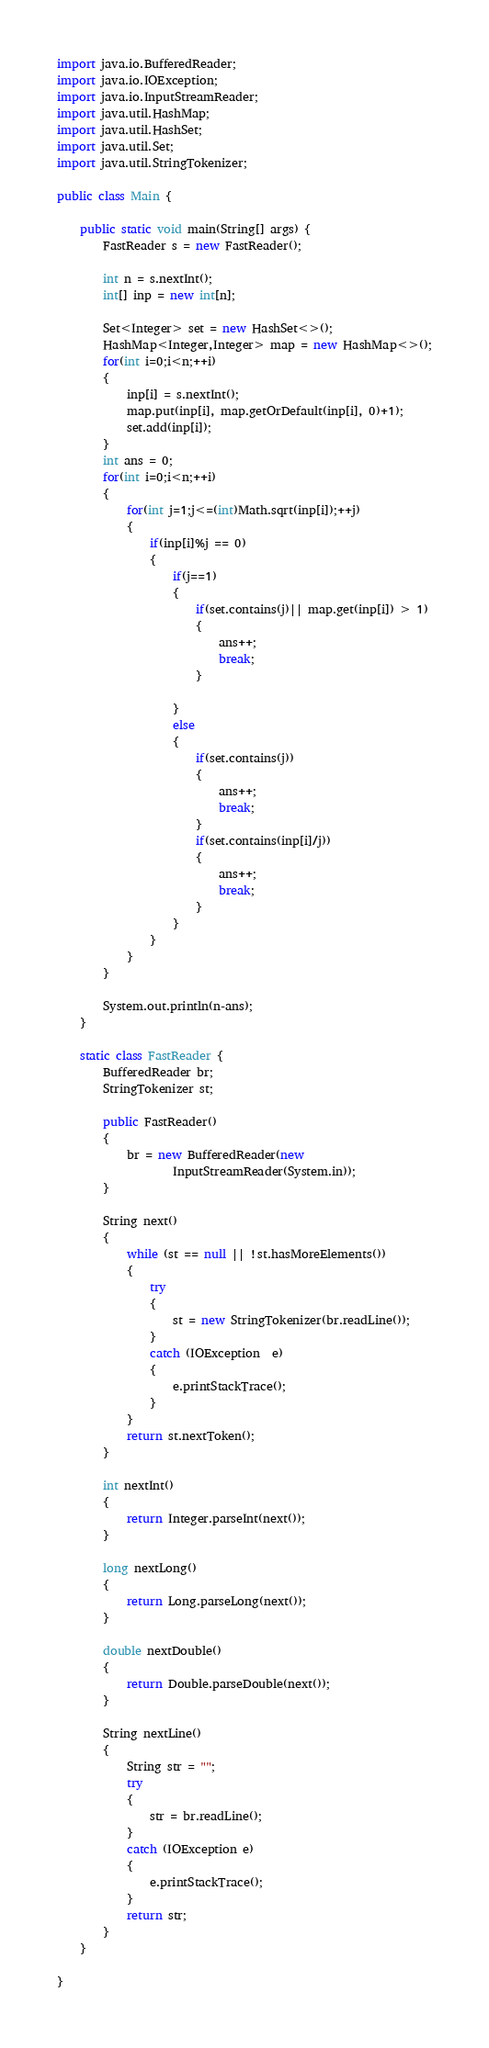<code> <loc_0><loc_0><loc_500><loc_500><_Java_>import java.io.BufferedReader;
import java.io.IOException;
import java.io.InputStreamReader;
import java.util.HashMap;
import java.util.HashSet;
import java.util.Set;
import java.util.StringTokenizer;

public class Main {

	public static void main(String[] args) {
		FastReader s = new FastReader();
	
		int n = s.nextInt();
		int[] inp = new int[n];
		
		Set<Integer> set = new HashSet<>();
		HashMap<Integer,Integer> map = new HashMap<>();
		for(int i=0;i<n;++i)
		{
			inp[i] = s.nextInt();
			map.put(inp[i], map.getOrDefault(inp[i], 0)+1);
			set.add(inp[i]);
		}
		int ans = 0;
		for(int i=0;i<n;++i)
		{
			for(int j=1;j<=(int)Math.sqrt(inp[i]);++j)
			{
				if(inp[i]%j == 0)
				{
					if(j==1)
					{
						if(set.contains(j)|| map.get(inp[i]) > 1)
						{
							ans++;
							break;
						}
							
					}
					else
					{
						if(set.contains(j))
						{
							ans++;
							break;
						}
						if(set.contains(inp[i]/j))
						{
							ans++;
							break;
						}
					}
				}
			}
		}
		
		System.out.println(n-ans);
	}
	
	static class FastReader {
        BufferedReader br;
        StringTokenizer st;
 
        public FastReader()
        {
            br = new BufferedReader(new
                    InputStreamReader(System.in));
        }
 
        String next()
        {
            while (st == null || !st.hasMoreElements())
            {
                try
                {
                    st = new StringTokenizer(br.readLine());
                }
                catch (IOException  e)
                {
                    e.printStackTrace();
                }
            }
            return st.nextToken();
        }
 
        int nextInt()
        {
            return Integer.parseInt(next());
        }
 
        long nextLong()
        {
            return Long.parseLong(next());
        }
 
        double nextDouble()
        {
            return Double.parseDouble(next());
        }
 
        String nextLine()
        {
            String str = "";
            try
            {
                str = br.readLine();
            }
            catch (IOException e)
            {
                e.printStackTrace();
            }
            return str;
        }
	}

}
</code> 